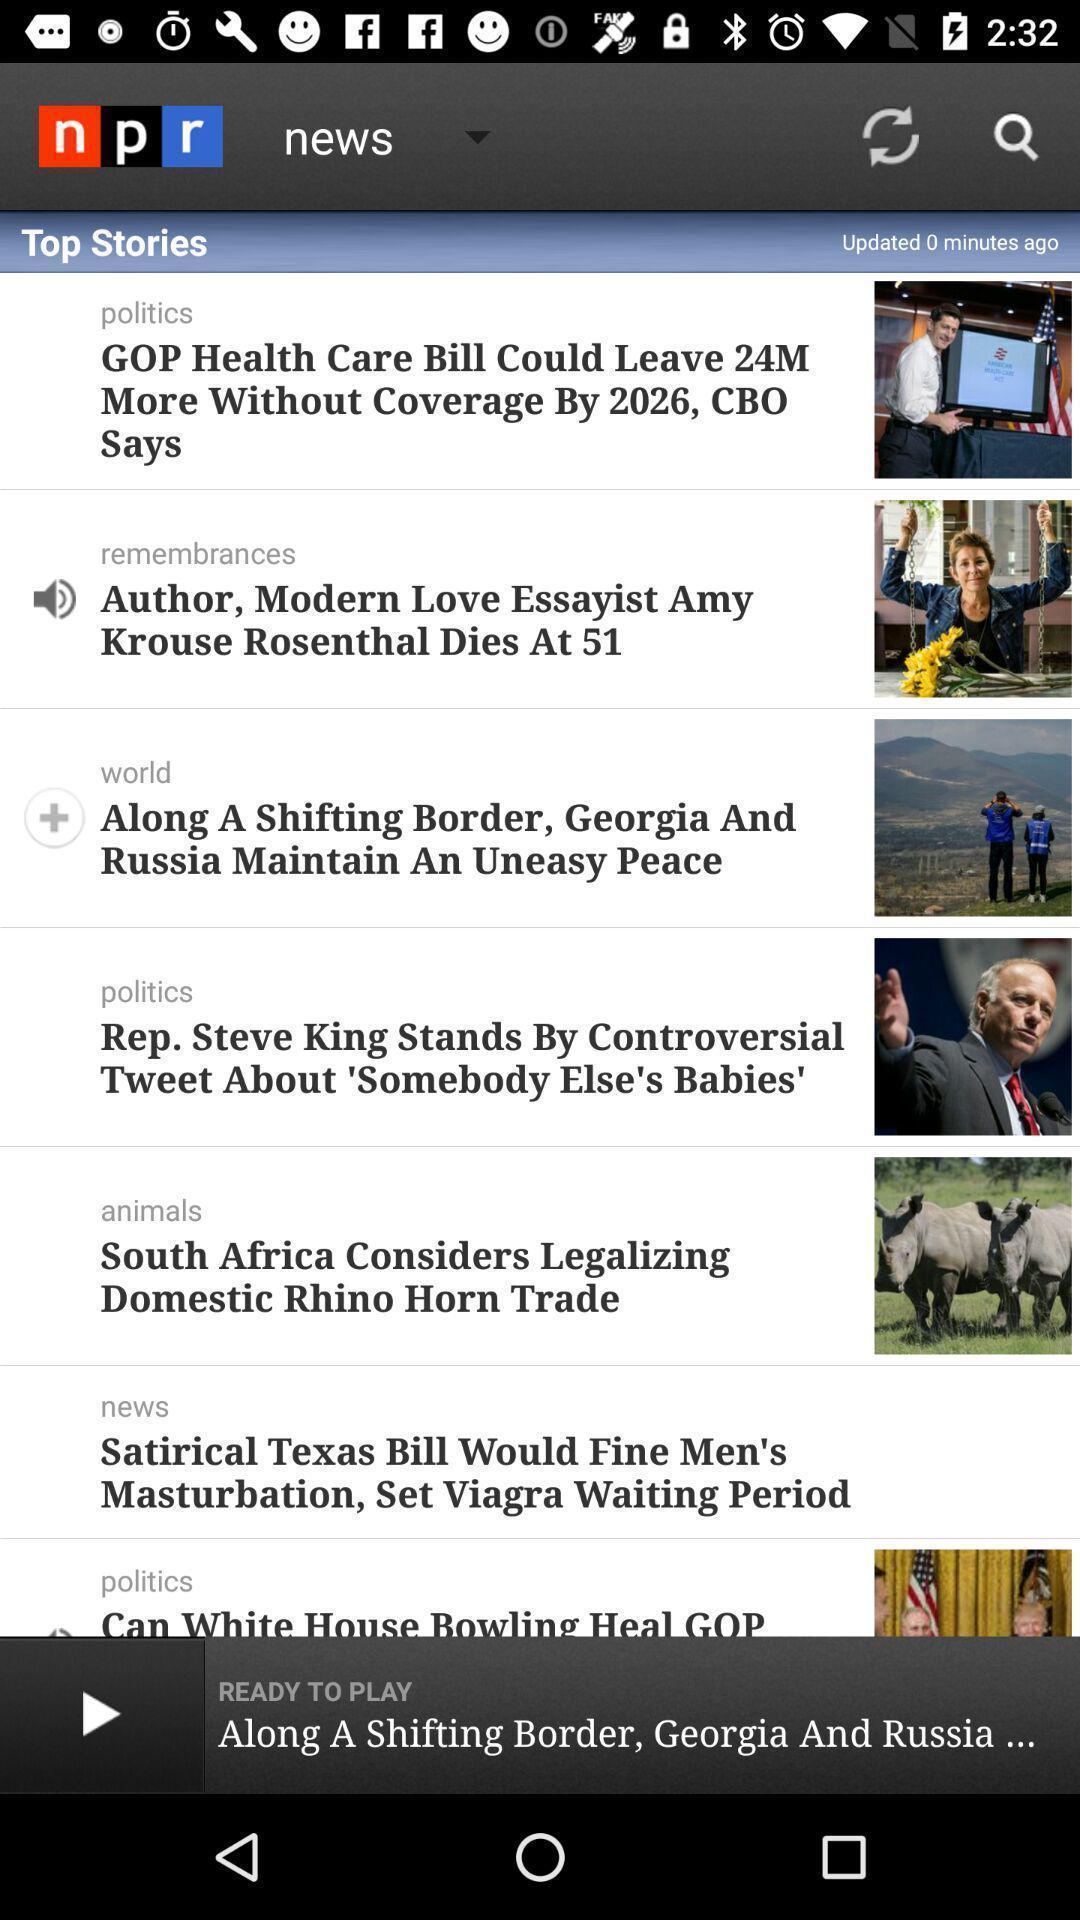Describe the key features of this screenshot. Page showing the top stories in a news app. 